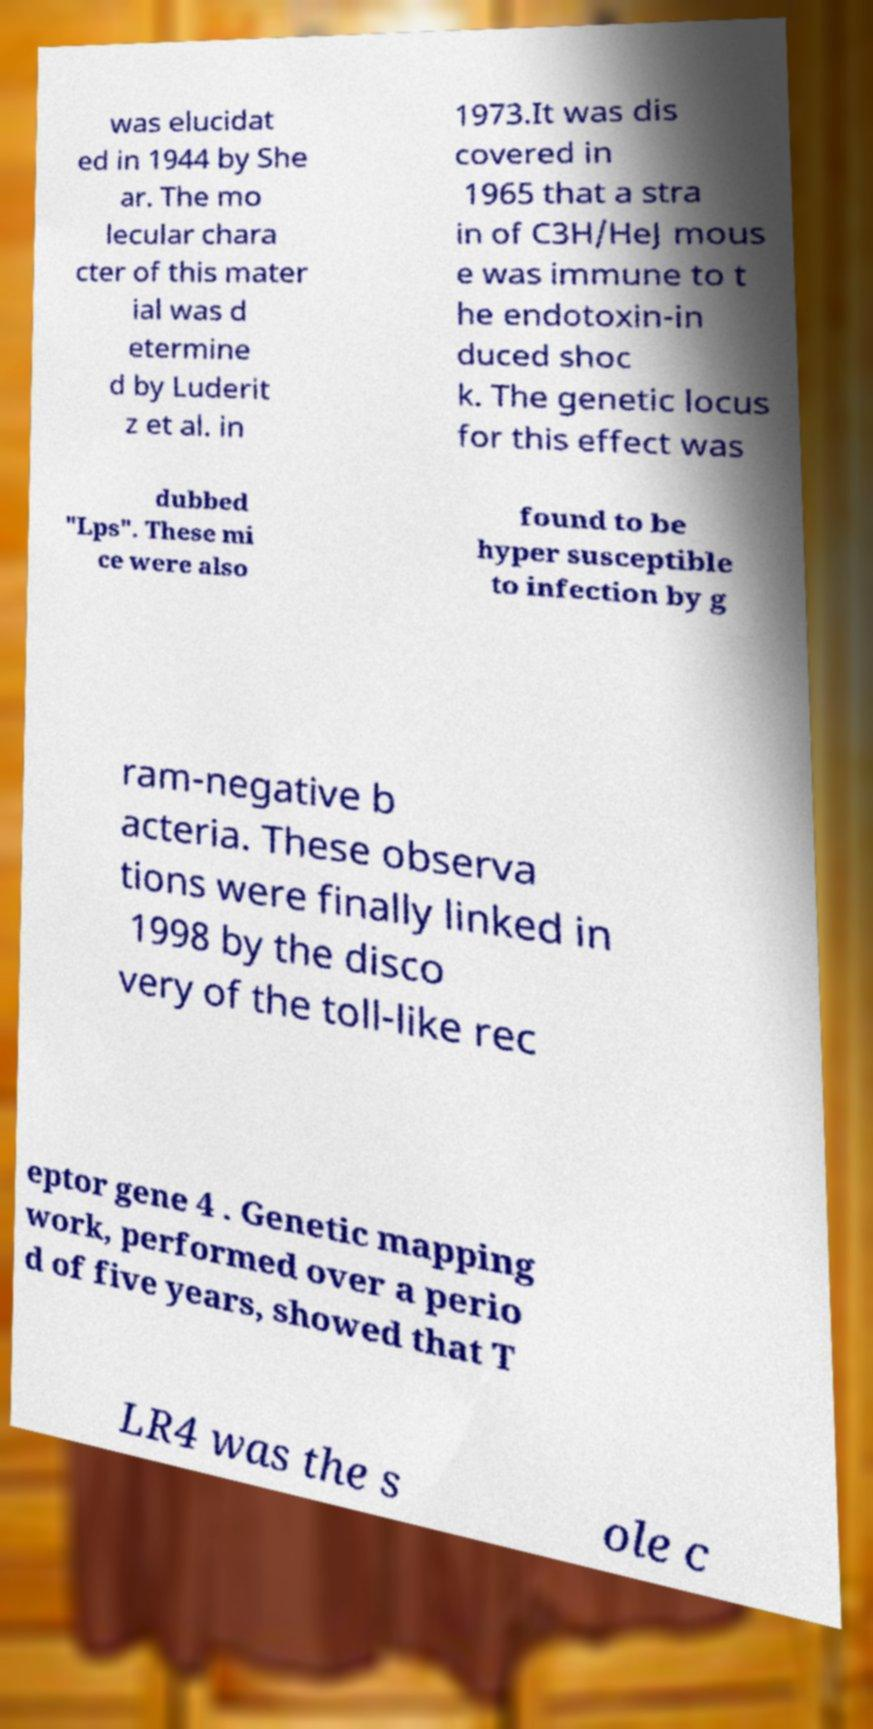There's text embedded in this image that I need extracted. Can you transcribe it verbatim? was elucidat ed in 1944 by She ar. The mo lecular chara cter of this mater ial was d etermine d by Luderit z et al. in 1973.It was dis covered in 1965 that a stra in of C3H/HeJ mous e was immune to t he endotoxin-in duced shoc k. The genetic locus for this effect was dubbed "Lps". These mi ce were also found to be hyper susceptible to infection by g ram-negative b acteria. These observa tions were finally linked in 1998 by the disco very of the toll-like rec eptor gene 4 . Genetic mapping work, performed over a perio d of five years, showed that T LR4 was the s ole c 